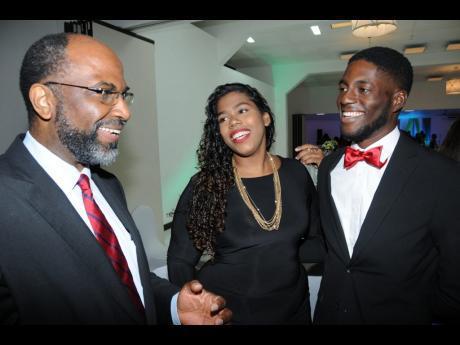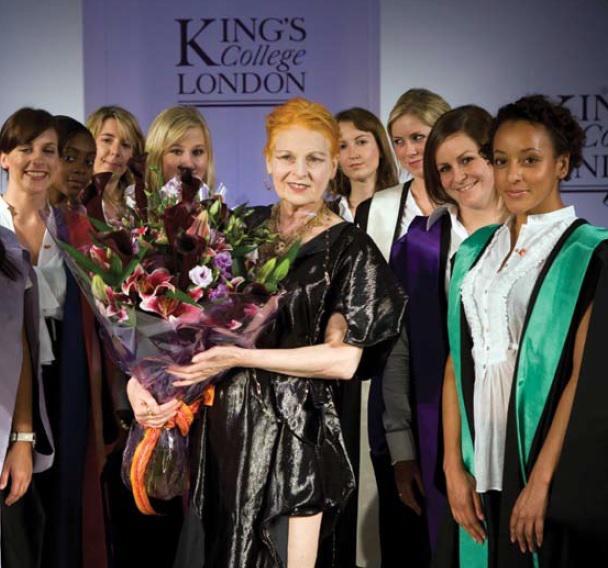The first image is the image on the left, the second image is the image on the right. Evaluate the accuracy of this statement regarding the images: "At least three people are wearing yellow graduation stoles in the image on the left.". Is it true? Answer yes or no. No. The first image is the image on the left, the second image is the image on the right. For the images shown, is this caption "Multiple young women in black and yellow stand in the foreground of an image." true? Answer yes or no. No. 